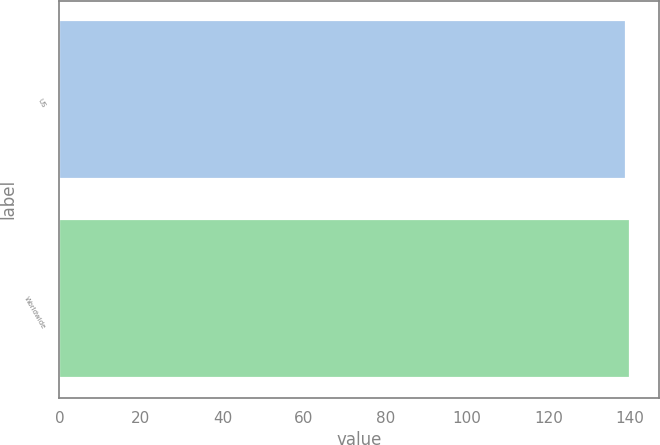<chart> <loc_0><loc_0><loc_500><loc_500><bar_chart><fcel>US<fcel>Worldwide<nl><fcel>139<fcel>140<nl></chart> 